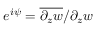Convert formula to latex. <formula><loc_0><loc_0><loc_500><loc_500>e ^ { i \psi } = \overline { { \partial _ { z } w } } / \partial _ { z } w</formula> 